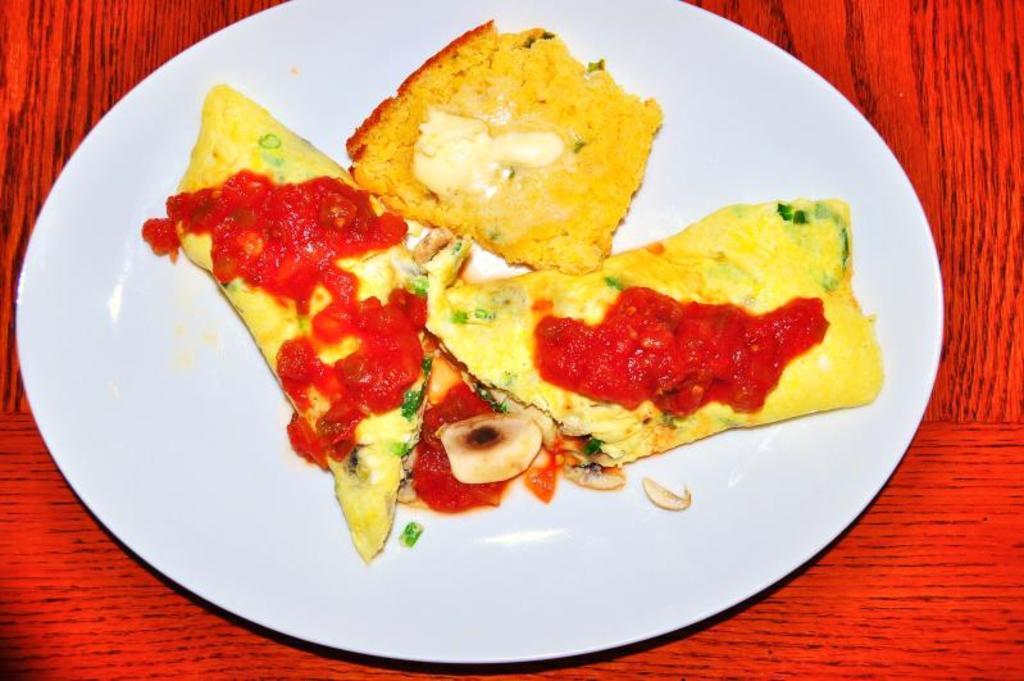Can you describe this image briefly? In this image I can see a white colored plate on the red and black colored object and in the plate I can see a food item which is yellow, green, red and cream in color. 